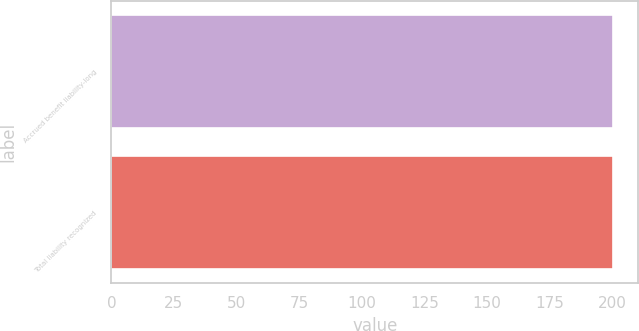<chart> <loc_0><loc_0><loc_500><loc_500><bar_chart><fcel>Accrued benefit liability-long<fcel>Total liability recognized<nl><fcel>200.3<fcel>200.4<nl></chart> 